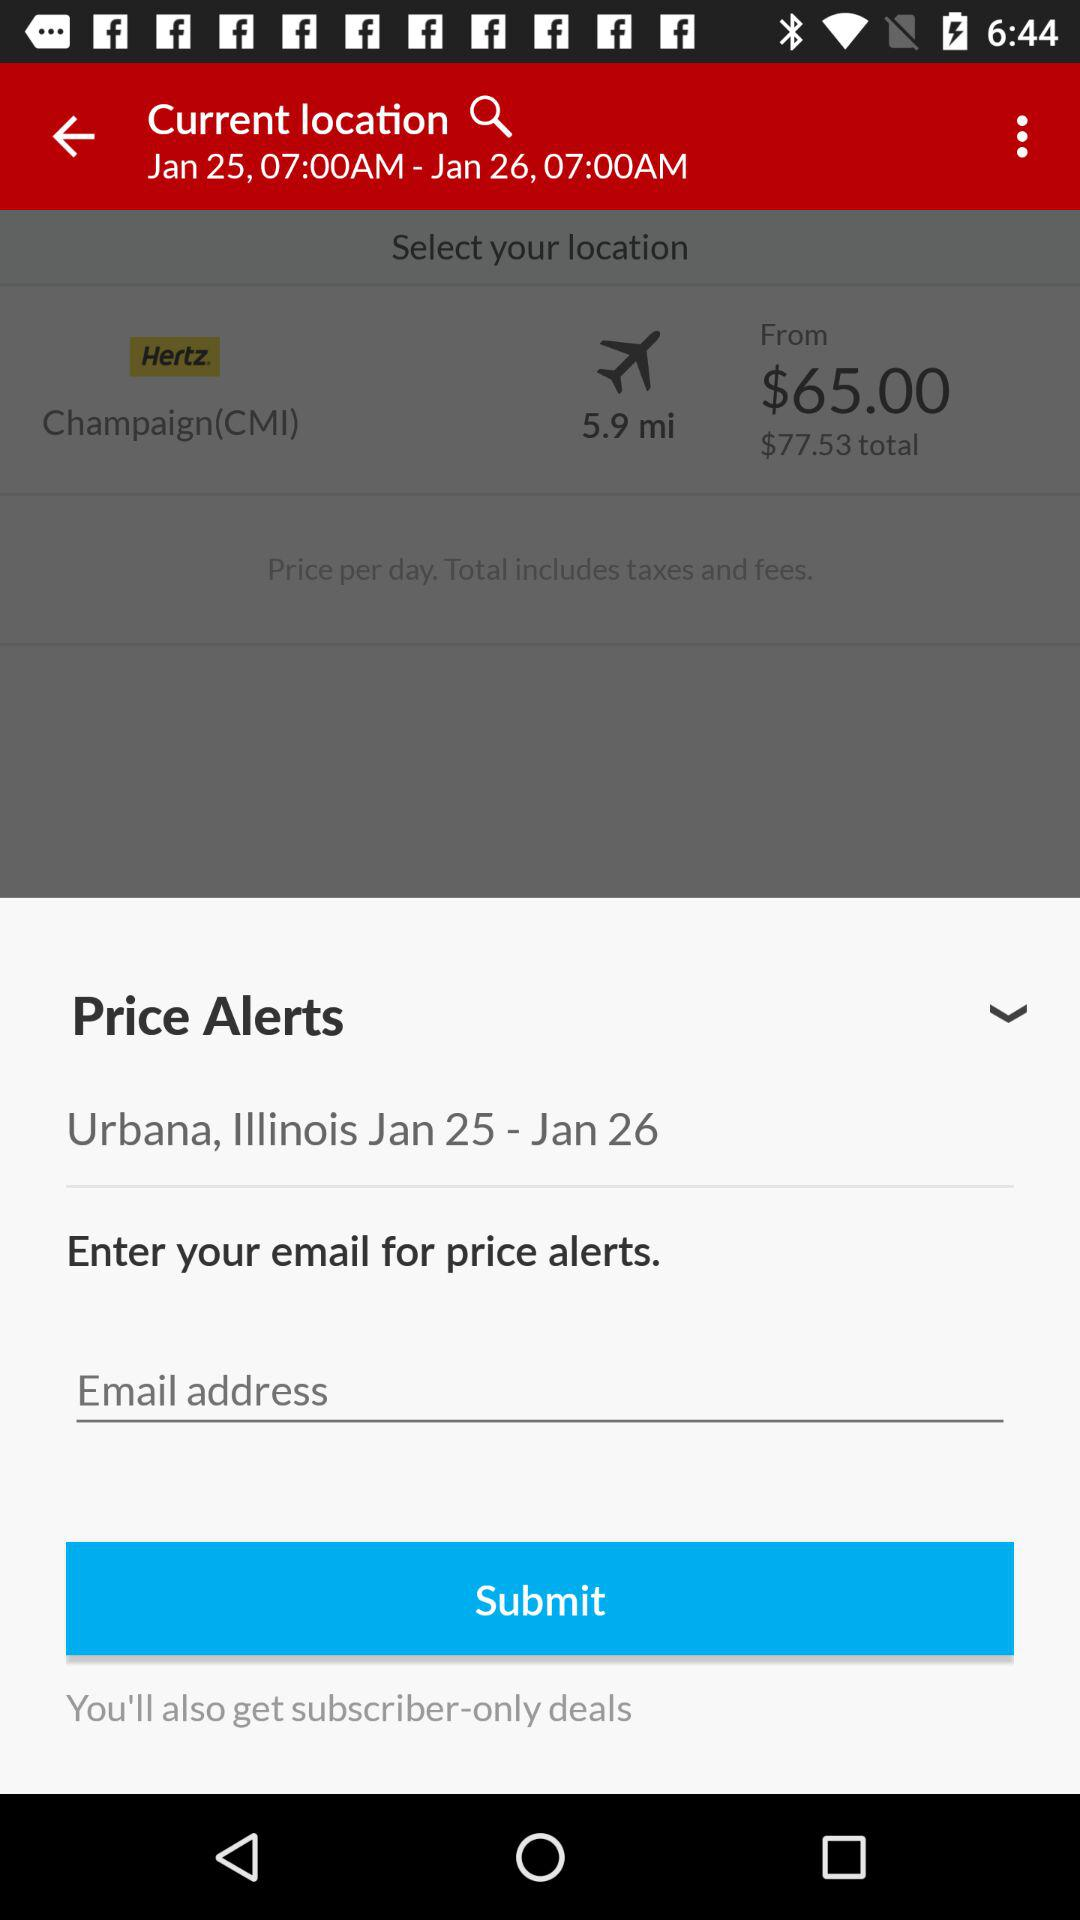What is the distance? The distance is 5.9 miles. 